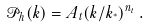<formula> <loc_0><loc_0><loc_500><loc_500>\mathcal { P } _ { h } ( k ) = A _ { t } ( k / k _ { ^ { * } } ) ^ { n _ { t } } \, .</formula> 